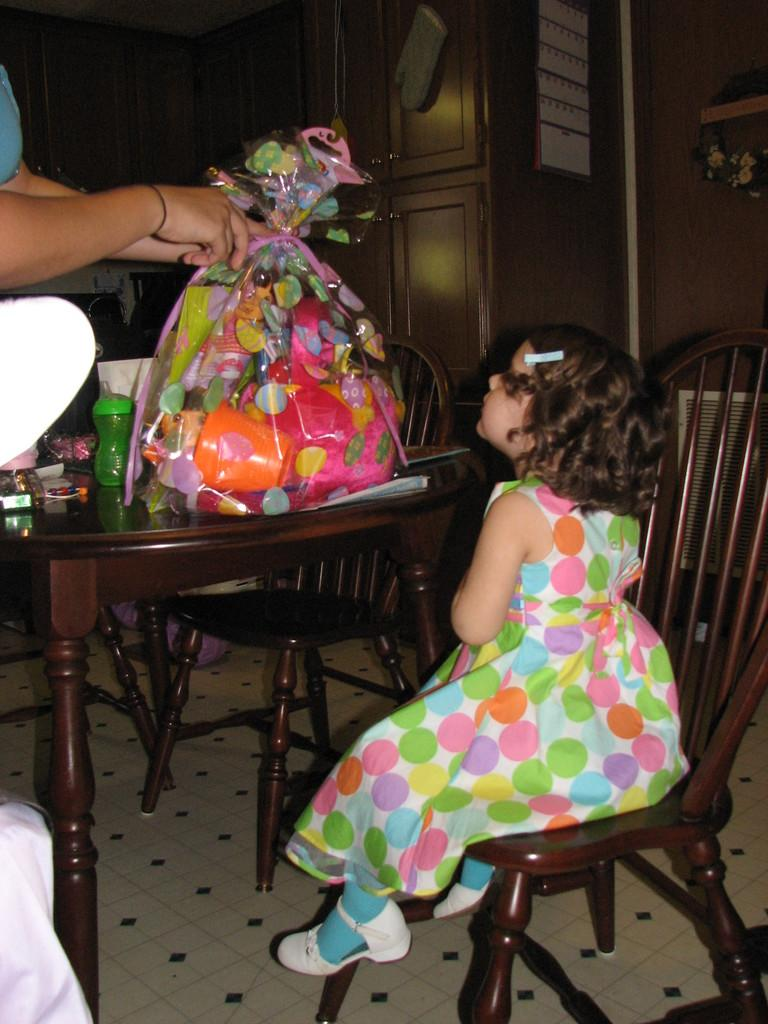What is the girl doing in the image? The girl is seated on a chair in the image. Who else is present in the image? There is a woman holding a bag of toys in the image. What objects can be seen on the table in the image? There are bottles on a table in the image. What type of ray is visible in the image? There is no ray present in the image. How does the image end? The image does not have an ending, as it is a static representation. 